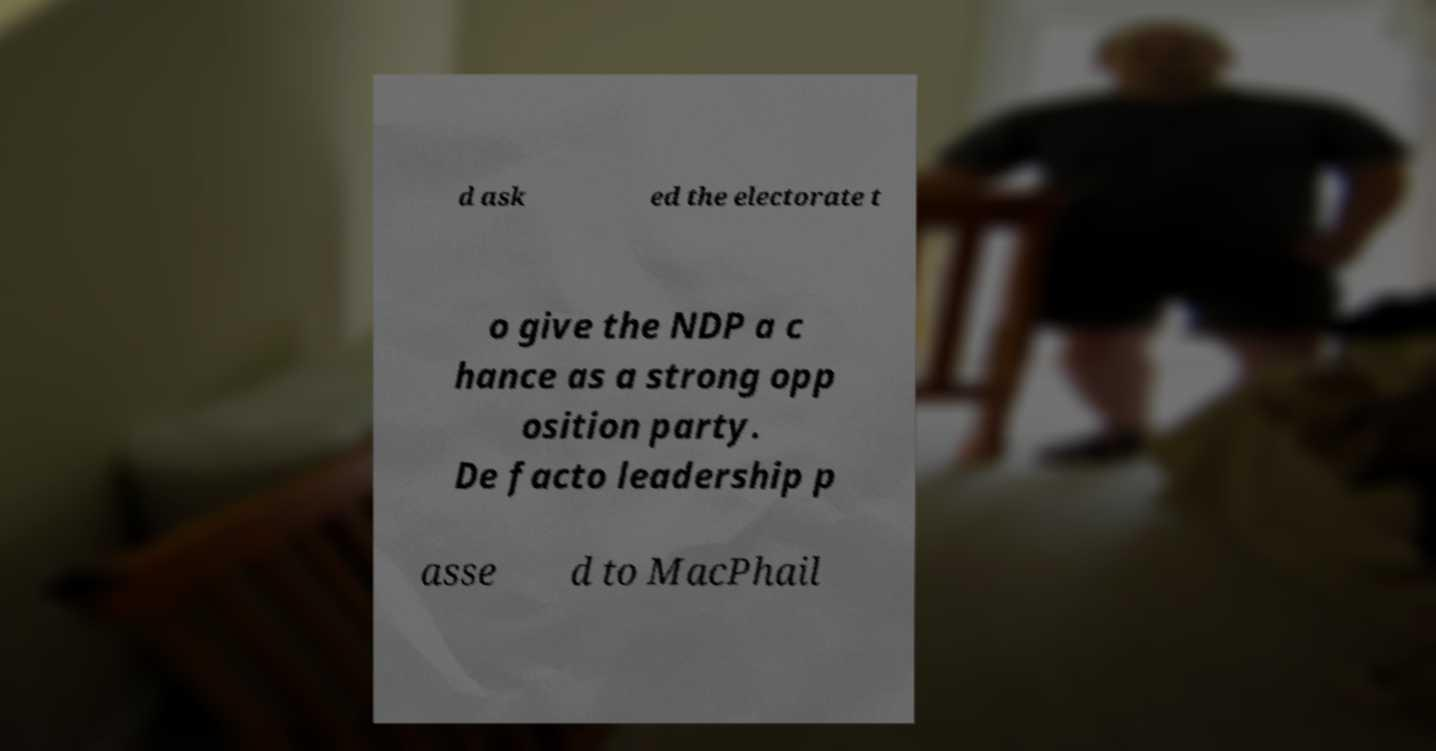Can you read and provide the text displayed in the image?This photo seems to have some interesting text. Can you extract and type it out for me? d ask ed the electorate t o give the NDP a c hance as a strong opp osition party. De facto leadership p asse d to MacPhail 